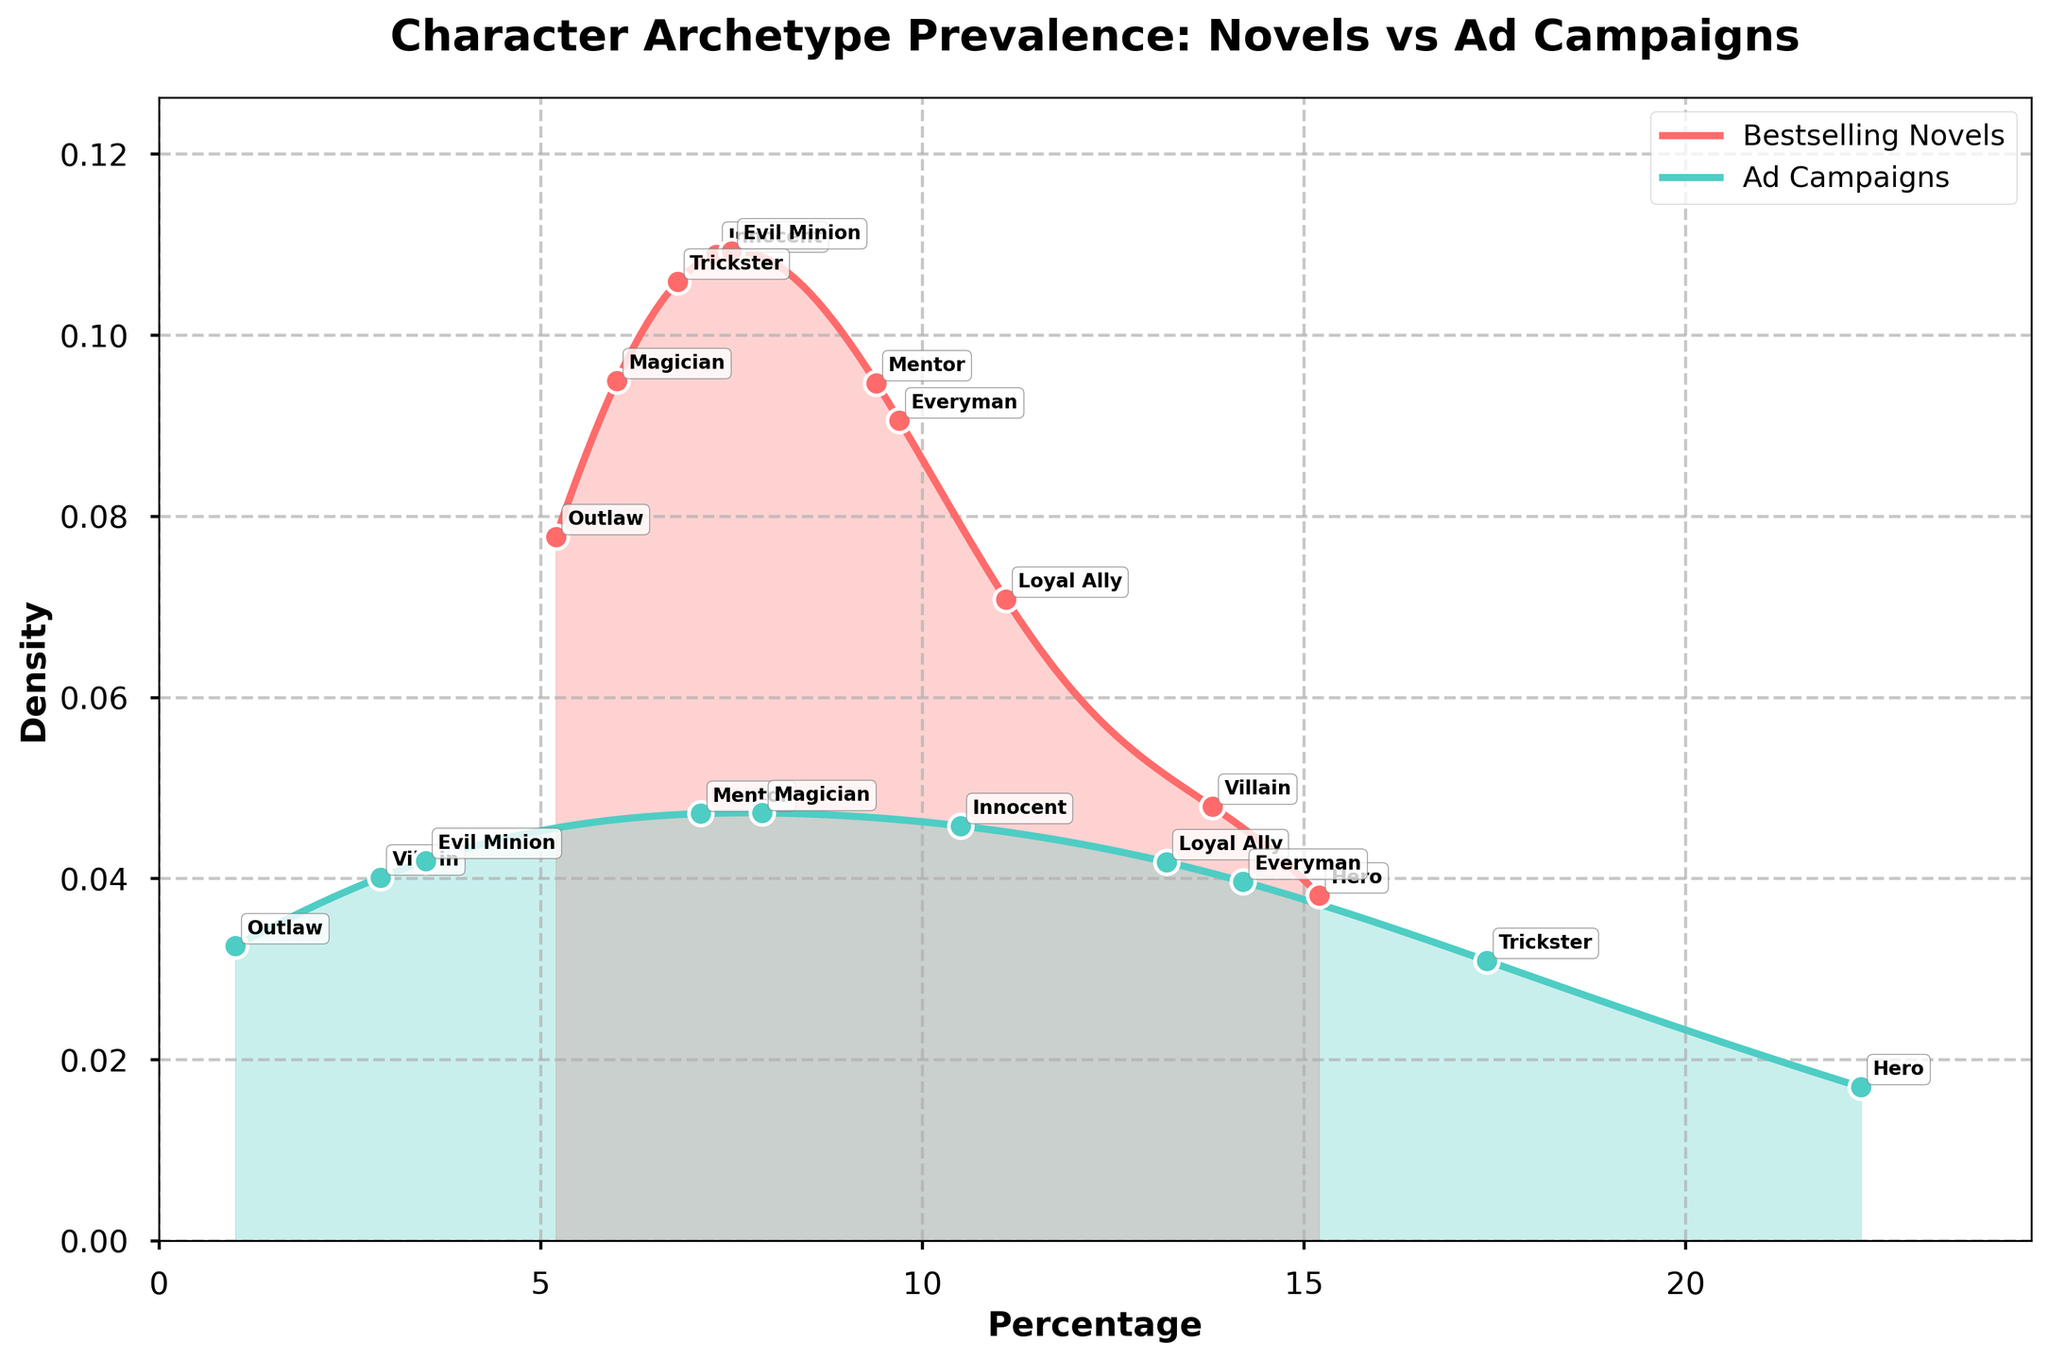What's the most prevalent character archetype in bestselling novels? Look at the density plot's highest point for the "Bestselling Novels" curve. The peak occurs at 15.2%, and it belongs to the Hero archetype.
Answer: Hero What's the most prevalent character archetype in ad campaigns? Look at the density plot's highest point for the "Ad Campaigns" curve. The peak occurs at 22.3%, and it corresponds to the Hero archetype.
Answer: Hero Which archetype has a higher prevalence in ad campaigns compared to bestselling novels? Identify the archetypes where the percentage for ad campaigns is greater than the percentage for bestselling novels. Examples include Hero (22.3% vs. 15.2%), Loyal Ally (13.2% vs. 11.1%), Innocent (10.5% vs. 7.3%), Trickster (17.4% vs. 6.8%), everyman (14.2% vs. 9.7%), and Magician (7.9% vs. 6.0%).
Answer: Hero, Loyal Ally, Innocent, Trickster, Everyman, Magician Which archetype has the lowest prevalence in ad campaigns? Look at the density plot's lowest point for "Ad Campaigns". The Outlaw archetype has the lowest value at 1.0%.
Answer: Outlaw Compare the prevalence of the Hero archetype between bestselling novels and ad campaigns. Locate the prevalence percentages of the Hero archetype for both categories. The Hero is 15.2% in novels and 22.3% in ad campaigns.
Answer: The Hero archetype is more prevalent in ad campaigns by 7.1% By how much does the prevalence of the Villain archetype differ between bestselling novels and ad campaigns? Locate the Villain prevalence percentages in both categories. The Villain is 13.8% in novels and 2.9% in ad campaigns. The difference is calculated as 13.8% - 2.9%.
Answer: 10.9% Which archetypes are more common in bestselling novels than in ad campaigns? Identify the archetypes where the percentage for bestselling novels is greater than the percentage for ad campaigns. Examples include Villain (13.8% vs. 2.9%), Mentor (9.4% vs. 7.1%), Evil Minion (7.5% vs. 3.5%), and Outlaw (5.2% vs. 1.0%).
Answer: Villain, Mentor, Evil Minion, Outlaw 